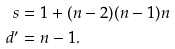<formula> <loc_0><loc_0><loc_500><loc_500>s & = 1 + ( n - 2 ) ( n - 1 ) n \\ d ^ { \prime } & = n - 1 .</formula> 